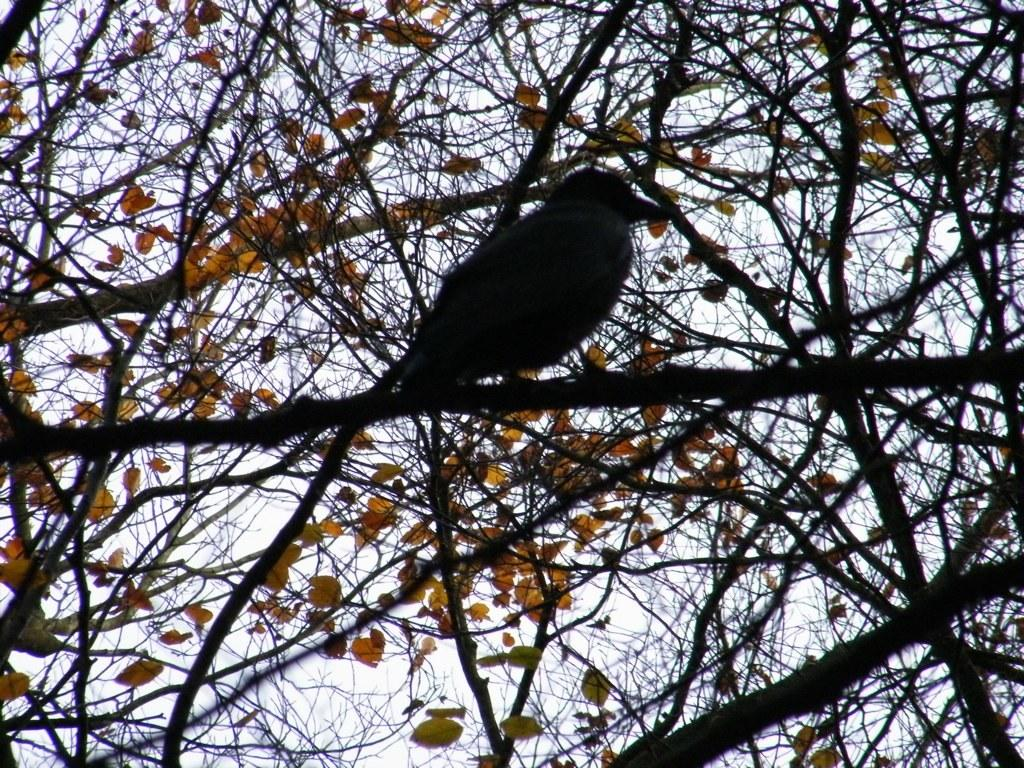What type of animal can be seen in the image? There is a bird in the image. Where is the bird located? The bird is sitting on a branch of a tree. What can be seen in the background of the image? The sky is visible in the image. Based on the presence of the sky and the bird's behavior, when do you think the image was taken? The image was likely taken during the day. What color is the quince in the image? There is no quince present in the image. How many eyes does the bird have in the image? The image does not show the bird's eyes, so it is impossible to determine the number of eyes. 